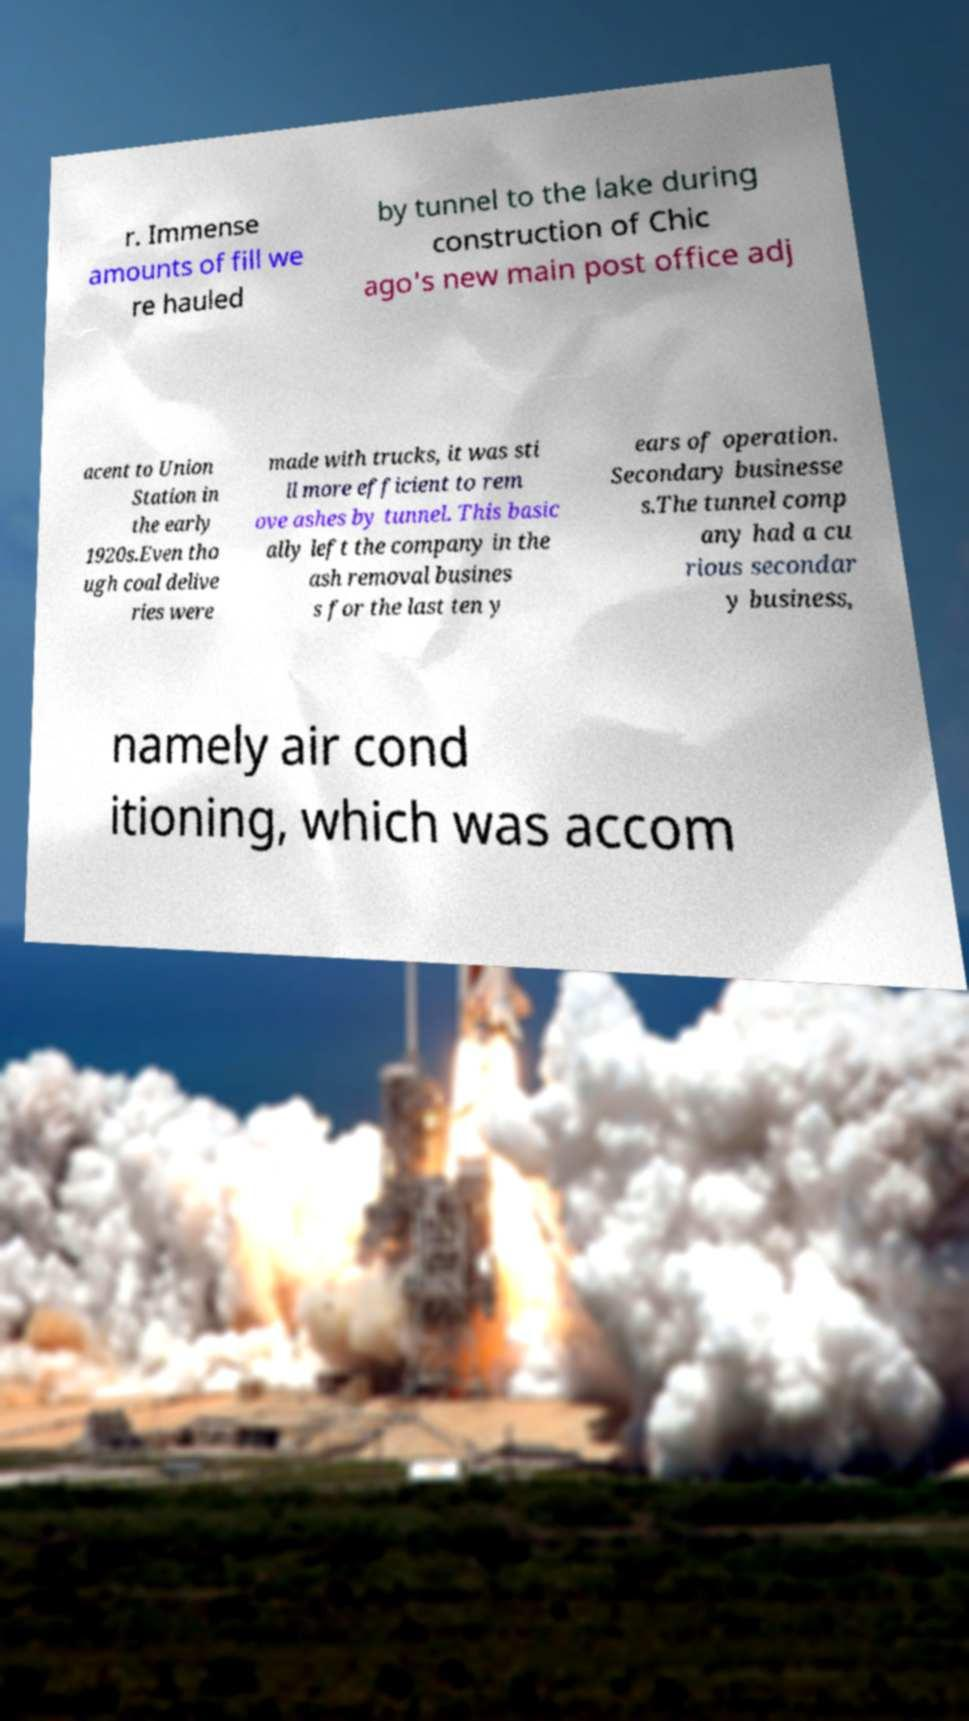Could you assist in decoding the text presented in this image and type it out clearly? r. Immense amounts of fill we re hauled by tunnel to the lake during construction of Chic ago's new main post office adj acent to Union Station in the early 1920s.Even tho ugh coal delive ries were made with trucks, it was sti ll more efficient to rem ove ashes by tunnel. This basic ally left the company in the ash removal busines s for the last ten y ears of operation. Secondary businesse s.The tunnel comp any had a cu rious secondar y business, namely air cond itioning, which was accom 